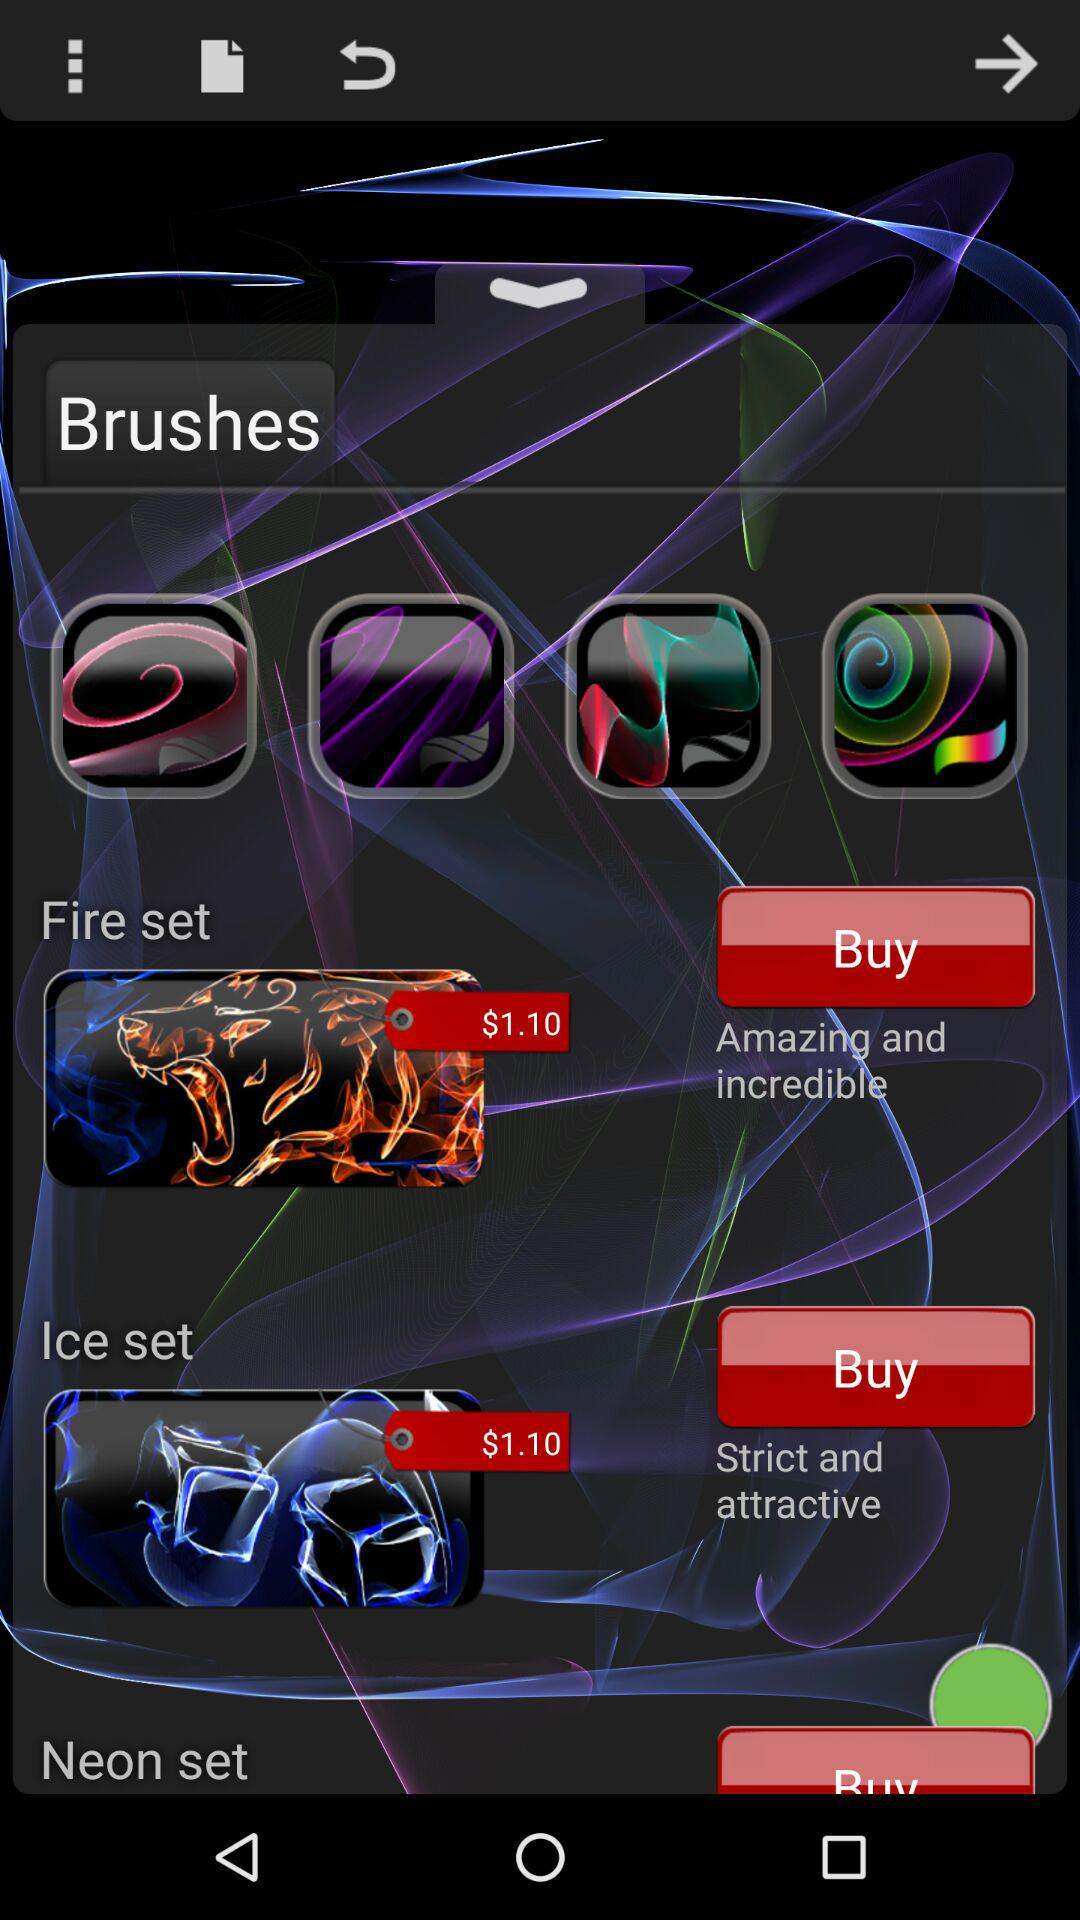What brushes have strict and attractive features? The brushes in the ice set have strict and attractive features. 